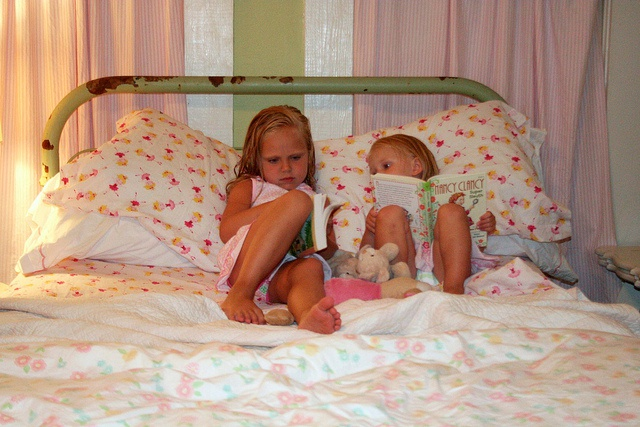Describe the objects in this image and their specific colors. I can see bed in beige, tan, lightgray, and darkgray tones, people in tan, brown, and maroon tones, people in beige, brown, maroon, and darkgray tones, book in beige, darkgray, gray, and brown tones, and teddy bear in beige, gray, and tan tones in this image. 